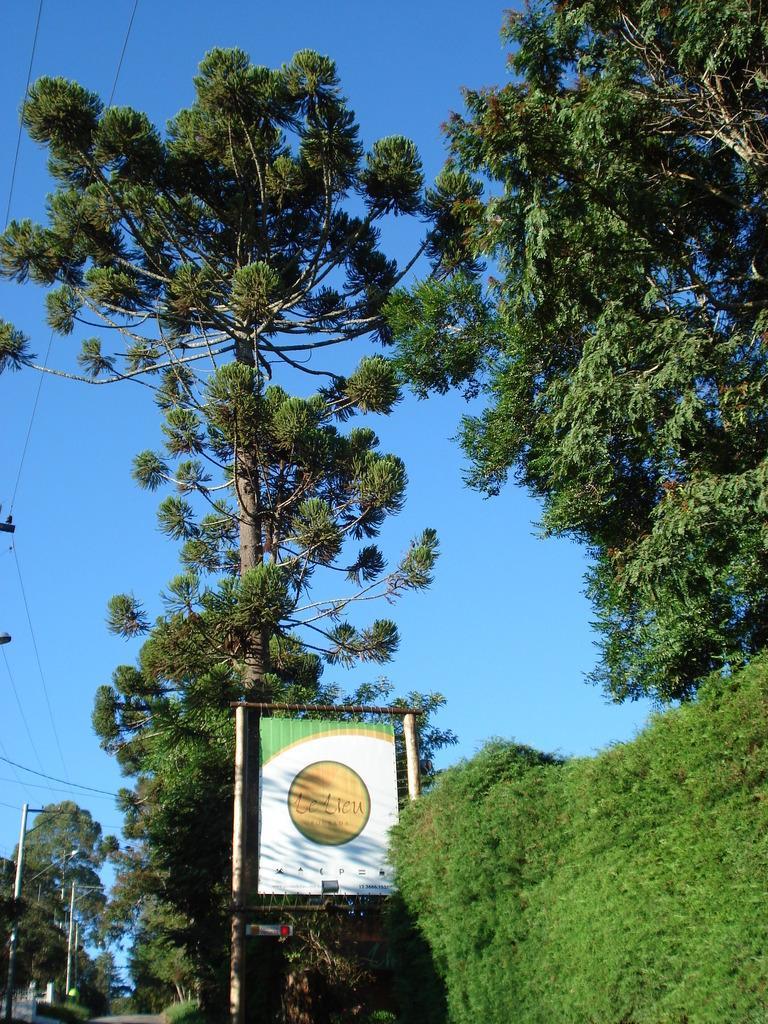Describe this image in one or two sentences. This image consists of many trees. In the front, there is a board. At the top, there is sky. 